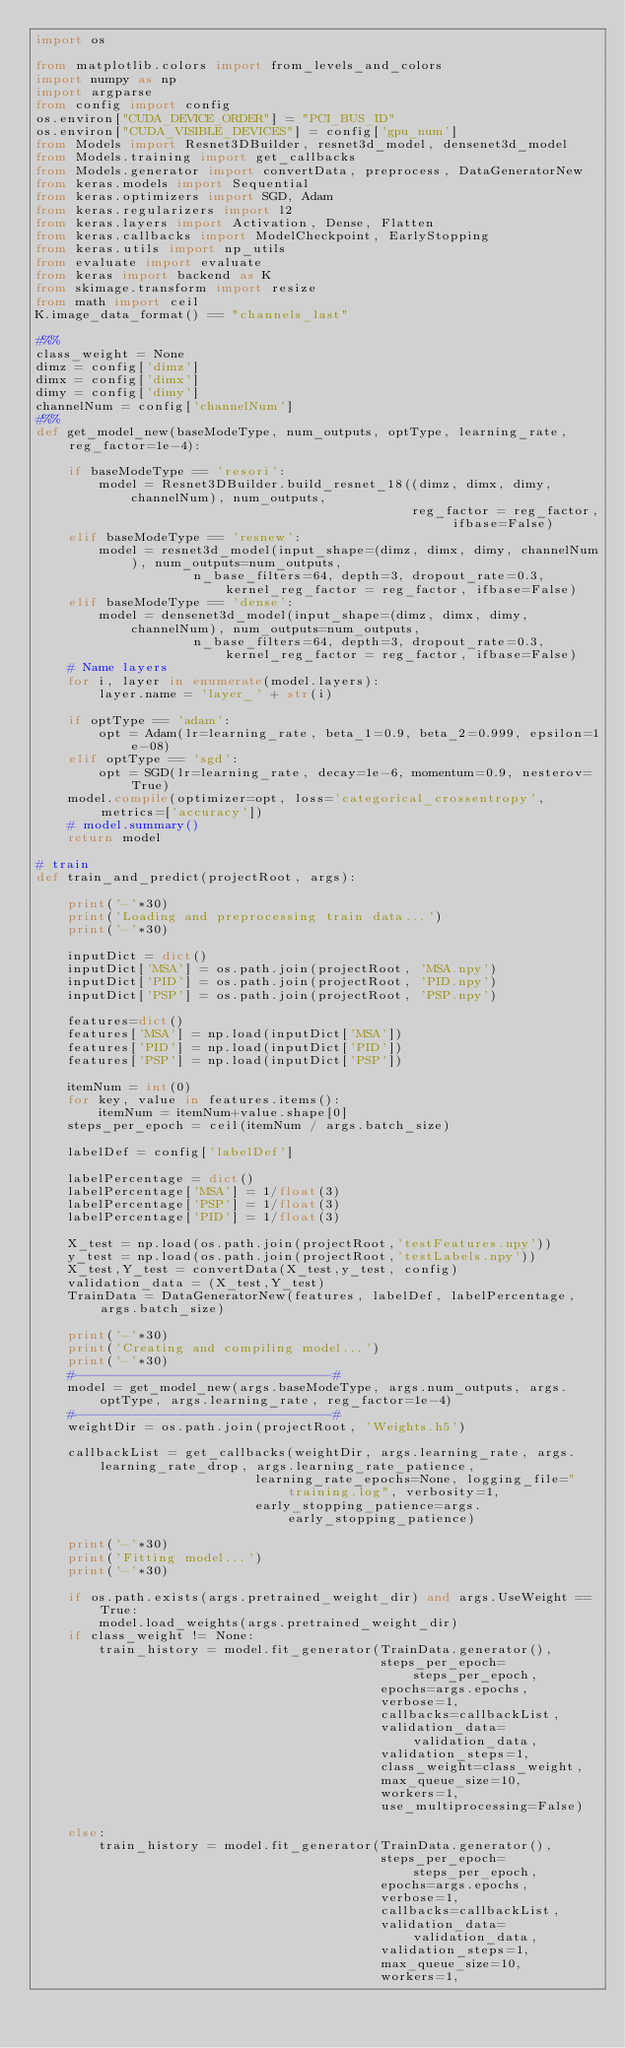Convert code to text. <code><loc_0><loc_0><loc_500><loc_500><_Python_>import os

from matplotlib.colors import from_levels_and_colors
import numpy as np
import argparse
from config import config
os.environ["CUDA_DEVICE_ORDER"] = "PCI_BUS_ID"
os.environ["CUDA_VISIBLE_DEVICES"] = config['gpu_num']
from Models import Resnet3DBuilder, resnet3d_model, densenet3d_model
from Models.training import get_callbacks
from Models.generator import convertData, preprocess, DataGeneratorNew
from keras.models import Sequential
from keras.optimizers import SGD, Adam
from keras.regularizers import l2
from keras.layers import Activation, Dense, Flatten
from keras.callbacks import ModelCheckpoint, EarlyStopping
from keras.utils import np_utils
from evaluate import evaluate
from keras import backend as K
from skimage.transform import resize
from math import ceil
K.image_data_format() == "channels_last"

#%%
class_weight = None
dimz = config['dimz']
dimx = config['dimx']
dimy = config['dimy']
channelNum = config['channelNum']
#%%
def get_model_new(baseModeType, num_outputs, optType, learning_rate, reg_factor=1e-4):
    
    if baseModeType == 'resori':
        model = Resnet3DBuilder.build_resnet_18((dimz, dimx, dimy, channelNum), num_outputs, 
                                                reg_factor = reg_factor, ifbase=False)
    elif baseModeType == 'resnew':
        model = resnet3d_model(input_shape=(dimz, dimx, dimy, channelNum), num_outputs=num_outputs, 
                    n_base_filters=64, depth=3, dropout_rate=0.3, kernel_reg_factor = reg_factor, ifbase=False)
    elif baseModeType == 'dense':
        model = densenet3d_model(input_shape=(dimz, dimx, dimy, channelNum), num_outputs=num_outputs, 
                    n_base_filters=64, depth=3, dropout_rate=0.3, kernel_reg_factor = reg_factor, ifbase=False)     
    # Name layers
    for i, layer in enumerate(model.layers):
        layer.name = 'layer_' + str(i)
    
    if optType == 'adam':
        opt = Adam(lr=learning_rate, beta_1=0.9, beta_2=0.999, epsilon=1e-08)
    elif optType == 'sgd':
        opt = SGD(lr=learning_rate, decay=1e-6, momentum=0.9, nesterov=True)        
    model.compile(optimizer=opt, loss='categorical_crossentropy', metrics=['accuracy'])
    # model.summary()
    return model

# train
def train_and_predict(projectRoot, args):
    
    print('-'*30)
    print('Loading and preprocessing train data...')
    print('-'*30) 

    inputDict = dict()
    inputDict['MSA'] = os.path.join(projectRoot, 'MSA.npy')
    inputDict['PID'] = os.path.join(projectRoot, 'PID.npy')
    inputDict['PSP'] = os.path.join(projectRoot, 'PSP.npy')

    features=dict()
    features['MSA'] = np.load(inputDict['MSA'])
    features['PID'] = np.load(inputDict['PID'])
    features['PSP'] = np.load(inputDict['PSP'])
    
    itemNum = int(0)
    for key, value in features.items():
        itemNum = itemNum+value.shape[0]
    steps_per_epoch = ceil(itemNum / args.batch_size) 

    labelDef = config['labelDef']
   
    labelPercentage = dict()
    labelPercentage['MSA'] = 1/float(3)
    labelPercentage['PSP'] = 1/float(3)
    labelPercentage['PID'] = 1/float(3)

    X_test = np.load(os.path.join(projectRoot,'testFeatures.npy'))
    y_test = np.load(os.path.join(projectRoot,'testLabels.npy'))
    X_test,Y_test = convertData(X_test,y_test, config) 
    validation_data = (X_test,Y_test) 
    TrainData = DataGeneratorNew(features, labelDef, labelPercentage, args.batch_size)
    
    print('-'*30)
    print('Creating and compiling model...')
    print('-'*30)
    #---------------------------------#
    model = get_model_new(args.baseModeType, args.num_outputs, args.optType, args.learning_rate, reg_factor=1e-4)
    #---------------------------------#
    weightDir = os.path.join(projectRoot, 'Weights.h5')
   
    callbackList = get_callbacks(weightDir, args.learning_rate, args.learning_rate_drop, args.learning_rate_patience, 
                            learning_rate_epochs=None, logging_file="training.log", verbosity=1,
                            early_stopping_patience=args.early_stopping_patience)
    
    print('-'*30)
    print('Fitting model...')
    print('-'*30)   

    if os.path.exists(args.pretrained_weight_dir) and args.UseWeight == True:
        model.load_weights(args.pretrained_weight_dir)
    if class_weight != None:
        train_history = model.fit_generator(TrainData.generator(), 
                                            steps_per_epoch=steps_per_epoch, 
                                            epochs=args.epochs, 
                                            verbose=1, 
                                            callbacks=callbackList, 
                                            validation_data=validation_data, 
                                            validation_steps=1, 
                                            class_weight=class_weight, 
                                            max_queue_size=10, 
                                            workers=1, 
                                            use_multiprocessing=False)

    else:
        train_history = model.fit_generator(TrainData.generator(), 
                                            steps_per_epoch=steps_per_epoch, 
                                            epochs=args.epochs, 
                                            verbose=1, 
                                            callbacks=callbackList, 
                                            validation_data=validation_data, 
                                            validation_steps=1, 
                                            max_queue_size=10, 
                                            workers=1, </code> 